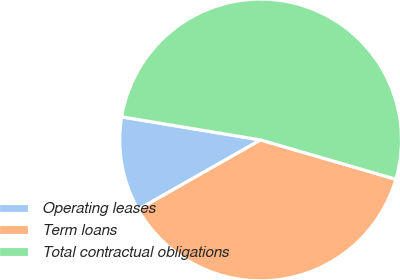Convert chart. <chart><loc_0><loc_0><loc_500><loc_500><pie_chart><fcel>Operating leases<fcel>Term loans<fcel>Total contractual obligations<nl><fcel>10.85%<fcel>37.27%<fcel>51.88%<nl></chart> 